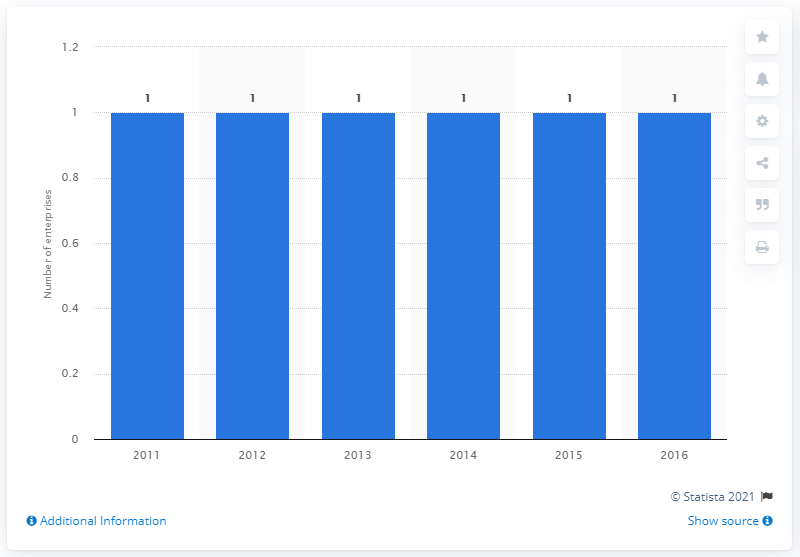Point out several critical features in this image. In the year 2014, there was only one enterprise in North Macedonia that was manufacturing cement. 